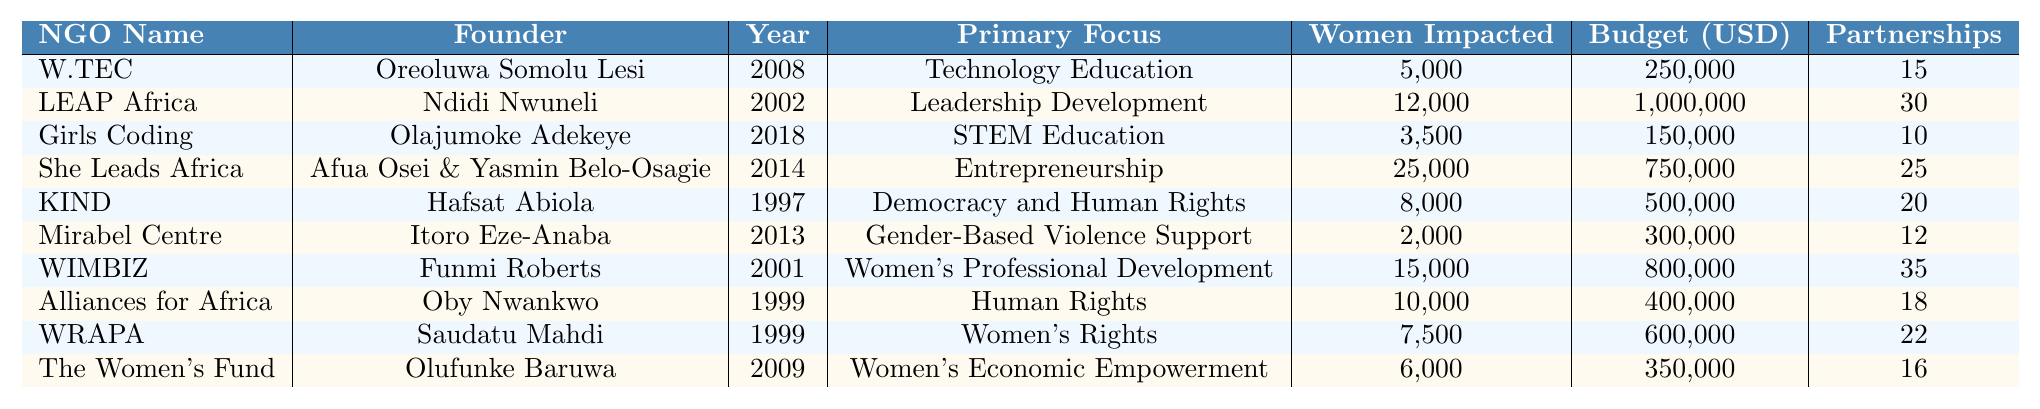What is the primary focus of the Women's Technology Empowerment Centre (W.TEC)? The primary focus is listed in the table next to its name. According to the table, W.TEC focuses on Technology Education.
Answer: Technology Education Which NGO has the highest number of women impacted in 2022? By reviewing the "Women Impacted 2022" column, She Leads Africa has the highest number listed at 25,000.
Answer: She Leads Africa What is the total annual budget of all the NGOs combined? To find the total budget, sum the annual budgets from the table: 250,000 + 1,000,000 + 150,000 + 750,000 + 500,000 + 300,000 + 800,000 + 400,000 + 600,000 + 350,000 = 5,100,000.
Answer: 5,100,000 How many partnerships does Women in Management, Business and Public Service (WIMBIZ) have? The number of partnerships for WIMBIZ is stated in the table; it shows 35 partnerships.
Answer: 35 Is the Mirabel Centre focused on women's rights? According to the "Primary Focus" column, the Mirabel Centre focuses on Gender-Based Violence Support, not directly on women's rights.
Answer: No What is the average number of women impacted across all NGOs? Add the women impacted for each NGO: 5000 + 12000 + 3500 + 25000 + 8000 + 2000 + 15000 + 10000 + 7500 + 6000 = 100,000. Then divide by the number of NGOs (10): 100,000 / 10 = 10,000.
Answer: 10,000 Which NGO was founded first and what is its primary focus? The founding years are listed, and KIND was founded in 1997. Its primary focus is Democracy and Human Rights.
Answer: Kudirat Initiative for Democracy (KIND), Democracy and Human Rights How many NGOs focus on economic empowerment or financial support for women? Review the "Primary Focus" column; The Women's Fund is focused on Women's Economic Empowerment, but no other NGO falls into this category according to the table.
Answer: 1 What is the difference in the number of social media followers between LEAP Africa and The Women's Fund? The number of followers for LEAP Africa is 200,000, and for The Women's Fund, it is 35,000. Calculate the difference: 200,000 - 35,000 = 165,000.
Answer: 165,000 Is it true that all listed NGOs are based in Nigeria? The table only includes NGOs based in Nigeria as shown in the "Country" column which states Nigeria for all entries.
Answer: Yes 